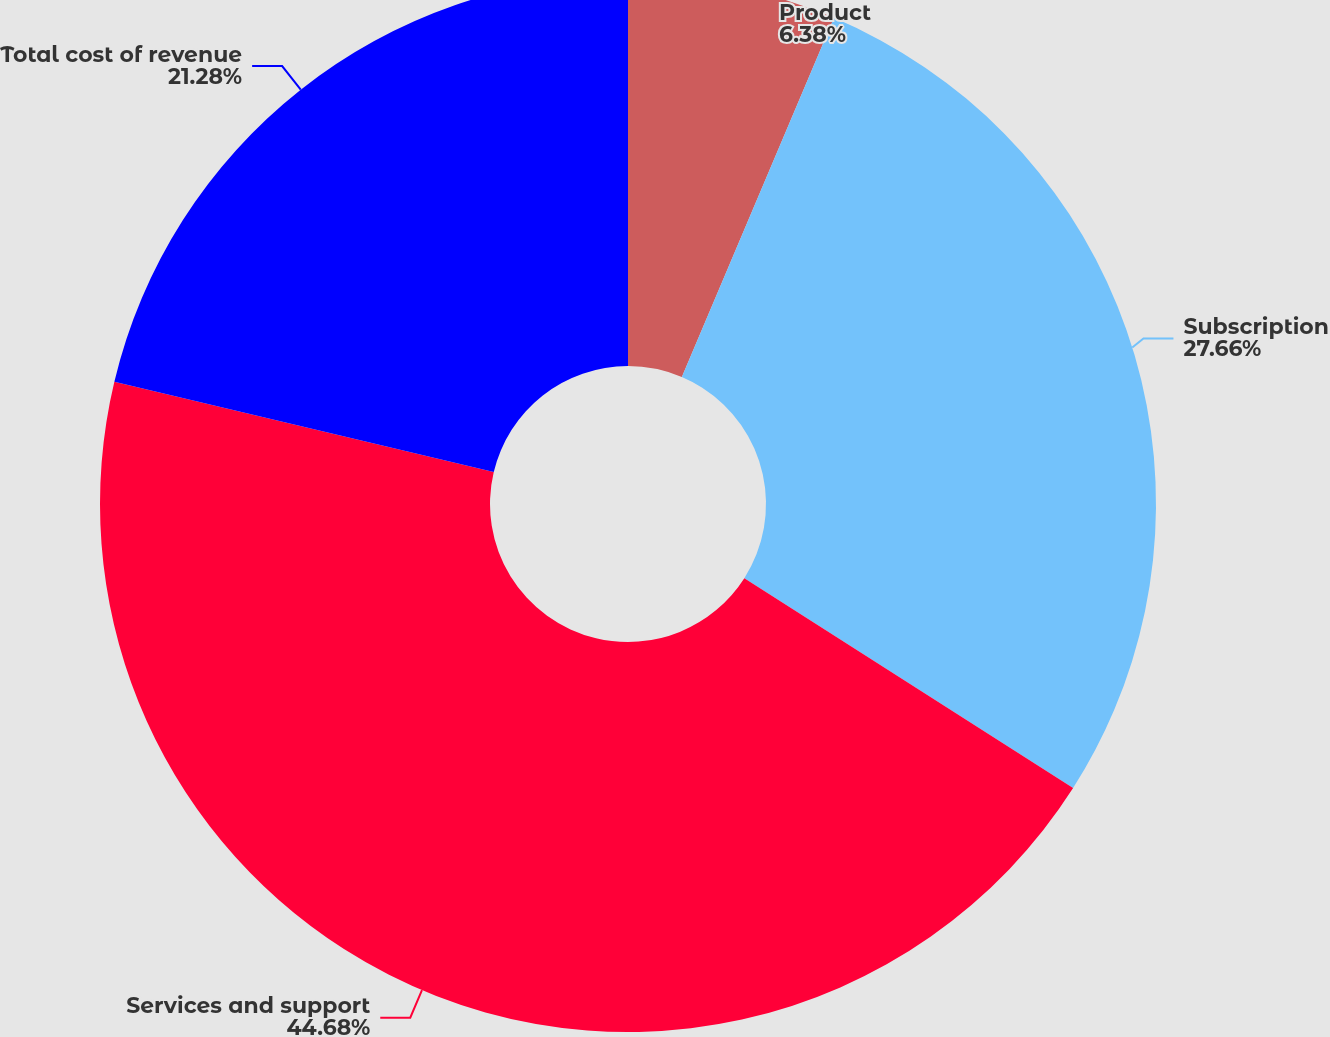<chart> <loc_0><loc_0><loc_500><loc_500><pie_chart><fcel>Product<fcel>Subscription<fcel>Services and support<fcel>Total cost of revenue<nl><fcel>6.38%<fcel>27.66%<fcel>44.68%<fcel>21.28%<nl></chart> 